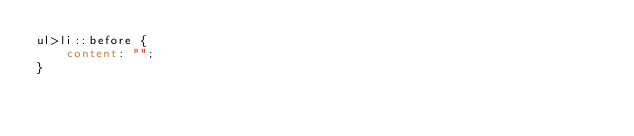Convert code to text. <code><loc_0><loc_0><loc_500><loc_500><_CSS_>ul>li::before {
    content: "";
}
</code> 